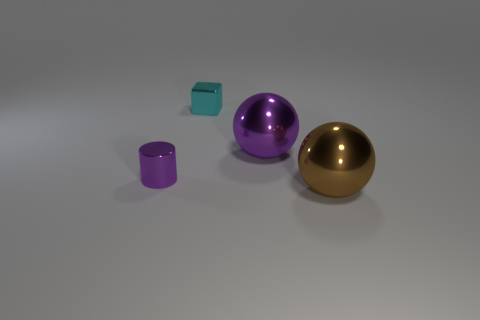Add 4 large brown objects. How many objects exist? 8 Subtract all blocks. How many objects are left? 3 Subtract 0 red balls. How many objects are left? 4 Subtract all gray rubber cubes. Subtract all cylinders. How many objects are left? 3 Add 3 purple things. How many purple things are left? 5 Add 4 cyan cubes. How many cyan cubes exist? 5 